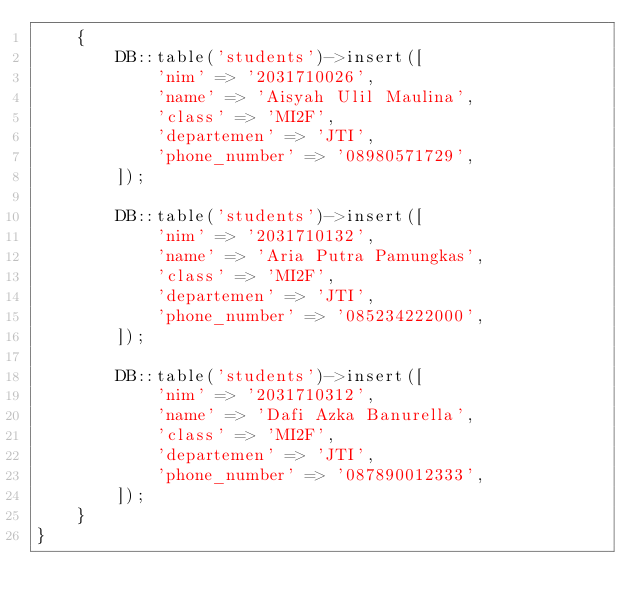<code> <loc_0><loc_0><loc_500><loc_500><_PHP_>    {
        DB::table('students')->insert([
            'nim' => '2031710026',
            'name' => 'Aisyah Ulil Maulina',
            'class' => 'MI2F',
            'departemen' => 'JTI',
            'phone_number' => '08980571729',
        ]);

        DB::table('students')->insert([
            'nim' => '2031710132',
            'name' => 'Aria Putra Pamungkas',
            'class' => 'MI2F',
            'departemen' => 'JTI',
            'phone_number' => '085234222000',
        ]);

        DB::table('students')->insert([
            'nim' => '2031710312',
            'name' => 'Dafi Azka Banurella',
            'class' => 'MI2F',
            'departemen' => 'JTI',
            'phone_number' => '087890012333',
        ]);
    }
}
</code> 